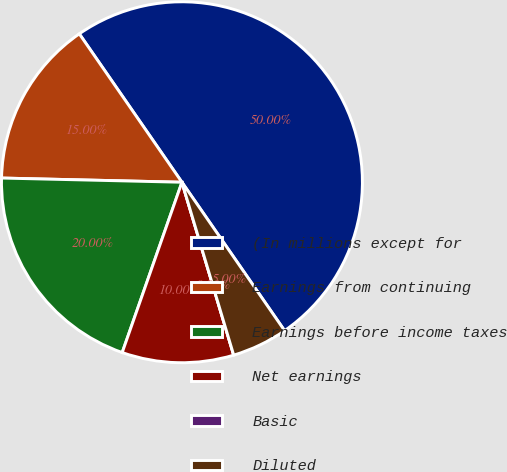Convert chart to OTSL. <chart><loc_0><loc_0><loc_500><loc_500><pie_chart><fcel>(In millions except for<fcel>Earnings from continuing<fcel>Earnings before income taxes<fcel>Net earnings<fcel>Basic<fcel>Diluted<nl><fcel>50.0%<fcel>15.0%<fcel>20.0%<fcel>10.0%<fcel>0.0%<fcel>5.0%<nl></chart> 